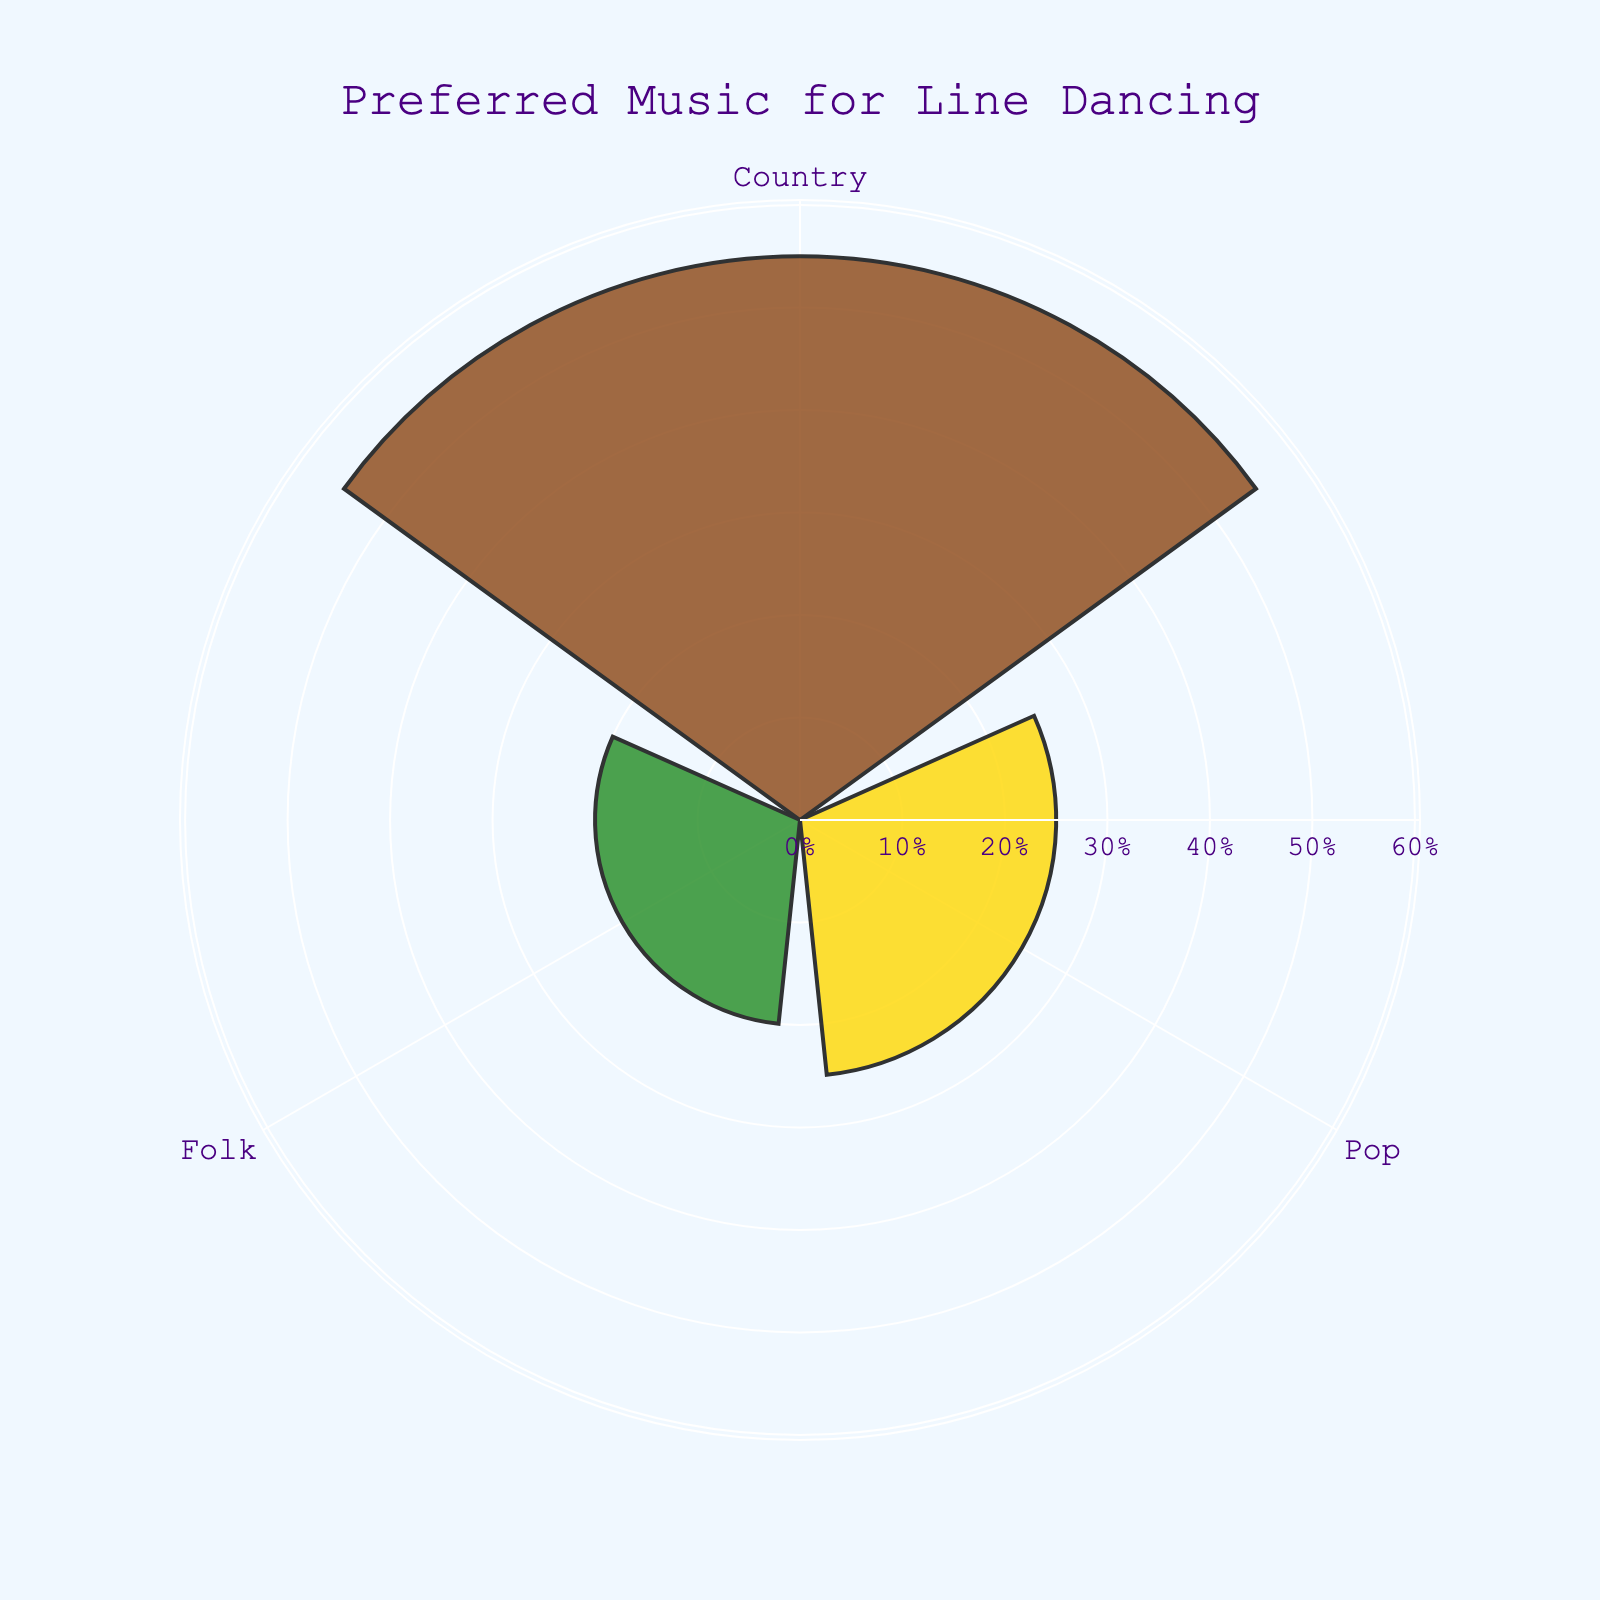What's the title of the chart? The title of the chart is located at the top center of the figure.
Answer: Preferred Music for Line Dancing How many genres are represented in the chart? The chart has three segments, each representing a different genre.
Answer: Three Which genre has the highest preference for line dancing? The segment with the longest bar represents the genre with the highest preference.
Answer: Country What's the percentage of participants who prefer folk music? The radial distance of the Folk segment indicates its percentage.
Answer: 20% What's the combined percentage of participants who prefer pop and folk music? Add the percentages of Pop and Folk, which are 25% and 20% respectively.
Answer: 45% How does the percentage of country music preference compare to the combined preference for pop and folk music? Compare the percentage of Country (55%) with the sum of Pop and Folk (45%).
Answer: Country has a higher preference by 10% Which color represents pop music in the chart? Identify the color associated with the Pop segment of the figure.
Answer: Gold What is the difference in percentage between the most and the least preferred music genres? Subtract the percentage of the least preferred genre (Folk, 20%) from the most preferred genre (Country, 55%).
Answer: 35% Is there any genre with an equal or higher percentage than 50%? Check the percentages for each genre to determine if any are equal to or higher than 50%.
Answer: Yes, Country What is the visual structure used to represent the data in the chart? Identify the chart type based on the radial structure and varying lengths representative of data values.
Answer: Rose chart 